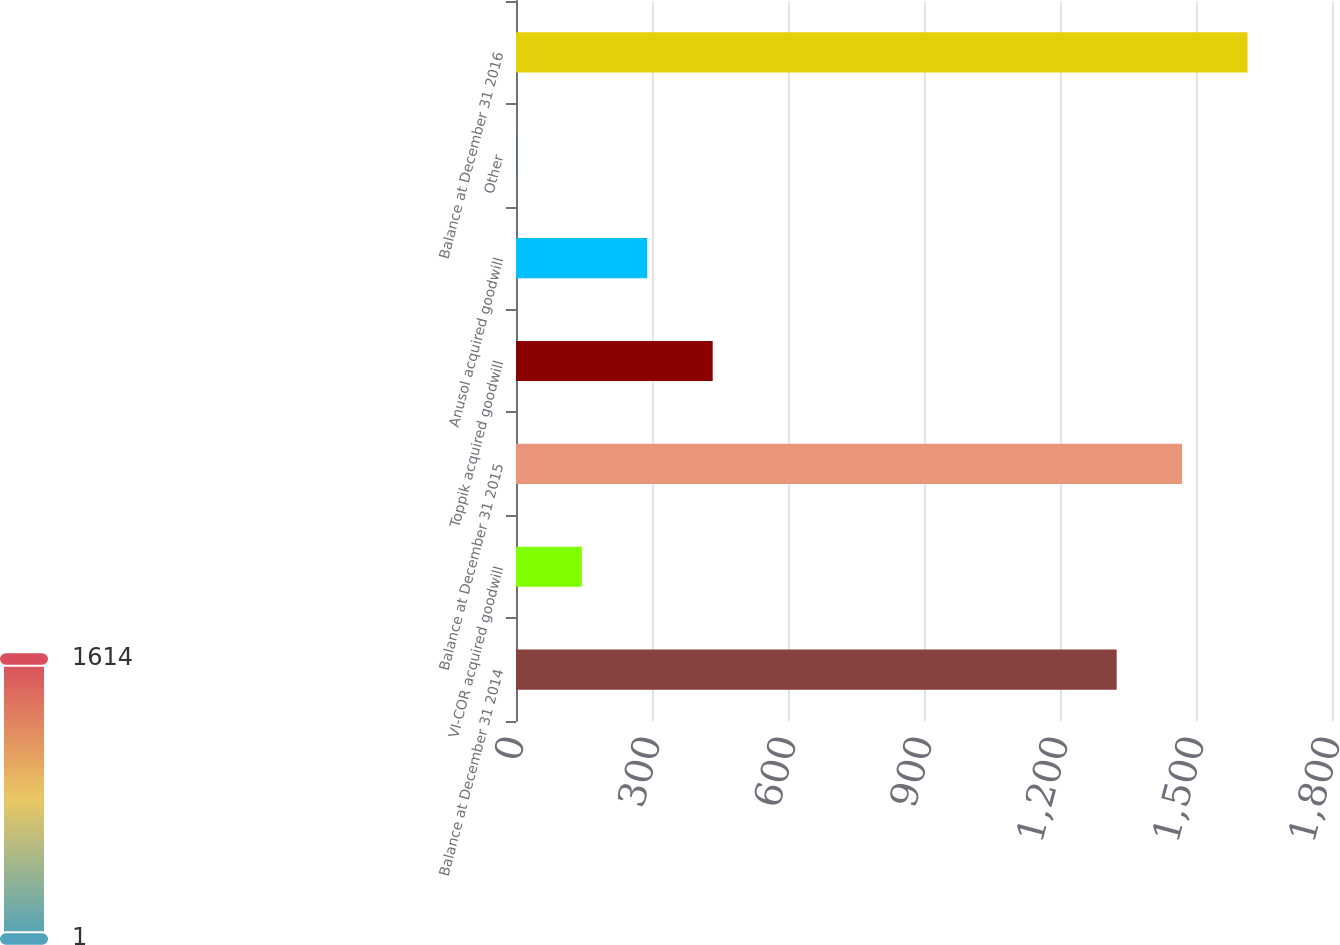<chart> <loc_0><loc_0><loc_500><loc_500><bar_chart><fcel>Balance at December 31 2014<fcel>VI-COR acquired goodwill<fcel>Balance at December 31 2015<fcel>Toppik acquired goodwill<fcel>Anusol acquired goodwill<fcel>Other<fcel>Balance at December 31 2016<nl><fcel>1325<fcel>145.22<fcel>1469.32<fcel>433.86<fcel>289.54<fcel>0.9<fcel>1613.64<nl></chart> 